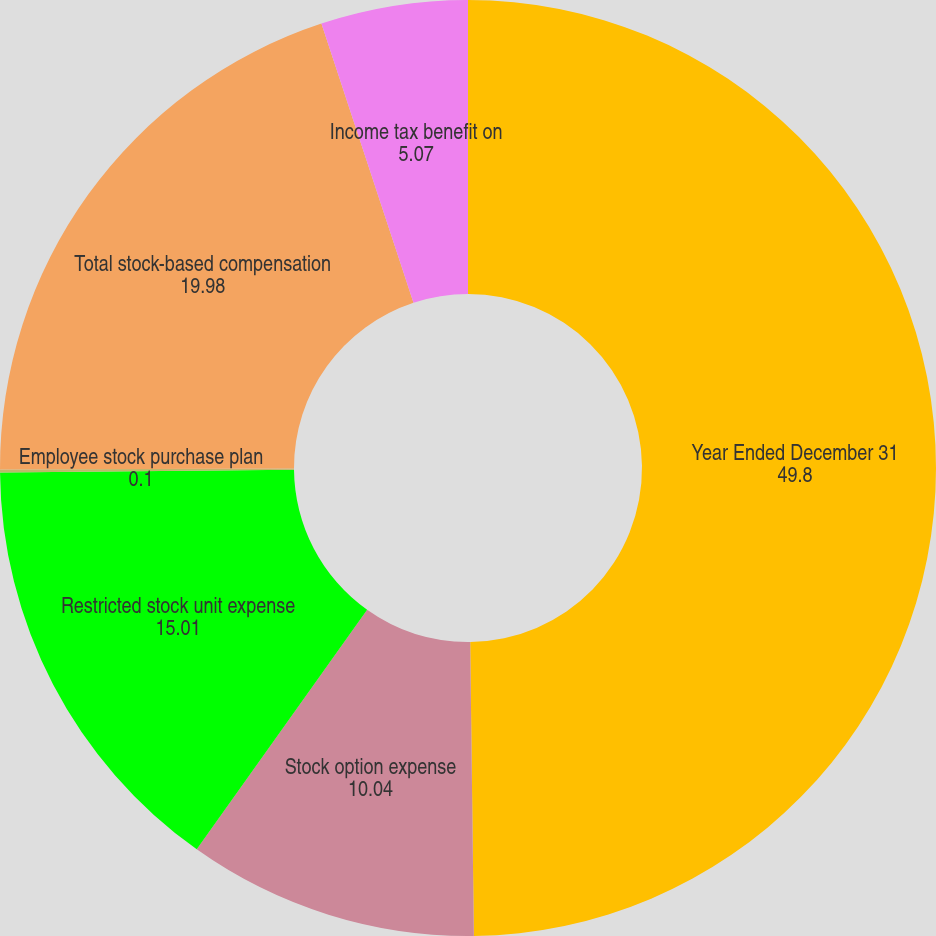<chart> <loc_0><loc_0><loc_500><loc_500><pie_chart><fcel>Year Ended December 31<fcel>Stock option expense<fcel>Restricted stock unit expense<fcel>Employee stock purchase plan<fcel>Total stock-based compensation<fcel>Income tax benefit on<nl><fcel>49.8%<fcel>10.04%<fcel>15.01%<fcel>0.1%<fcel>19.98%<fcel>5.07%<nl></chart> 